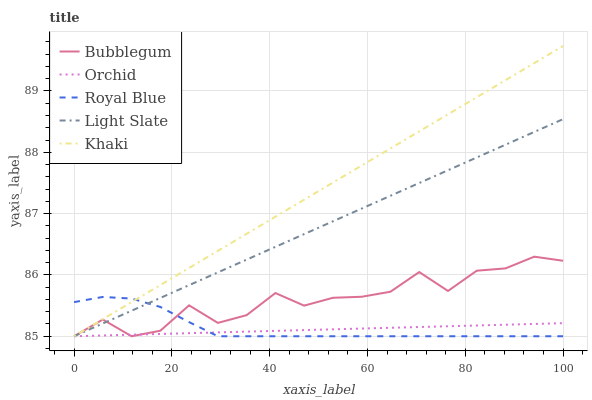Does Orchid have the minimum area under the curve?
Answer yes or no. Yes. Does Khaki have the maximum area under the curve?
Answer yes or no. Yes. Does Royal Blue have the minimum area under the curve?
Answer yes or no. No. Does Royal Blue have the maximum area under the curve?
Answer yes or no. No. Is Khaki the smoothest?
Answer yes or no. Yes. Is Bubblegum the roughest?
Answer yes or no. Yes. Is Royal Blue the smoothest?
Answer yes or no. No. Is Royal Blue the roughest?
Answer yes or no. No. Does Light Slate have the lowest value?
Answer yes or no. Yes. Does Khaki have the highest value?
Answer yes or no. Yes. Does Royal Blue have the highest value?
Answer yes or no. No. Does Orchid intersect Bubblegum?
Answer yes or no. Yes. Is Orchid less than Bubblegum?
Answer yes or no. No. Is Orchid greater than Bubblegum?
Answer yes or no. No. 